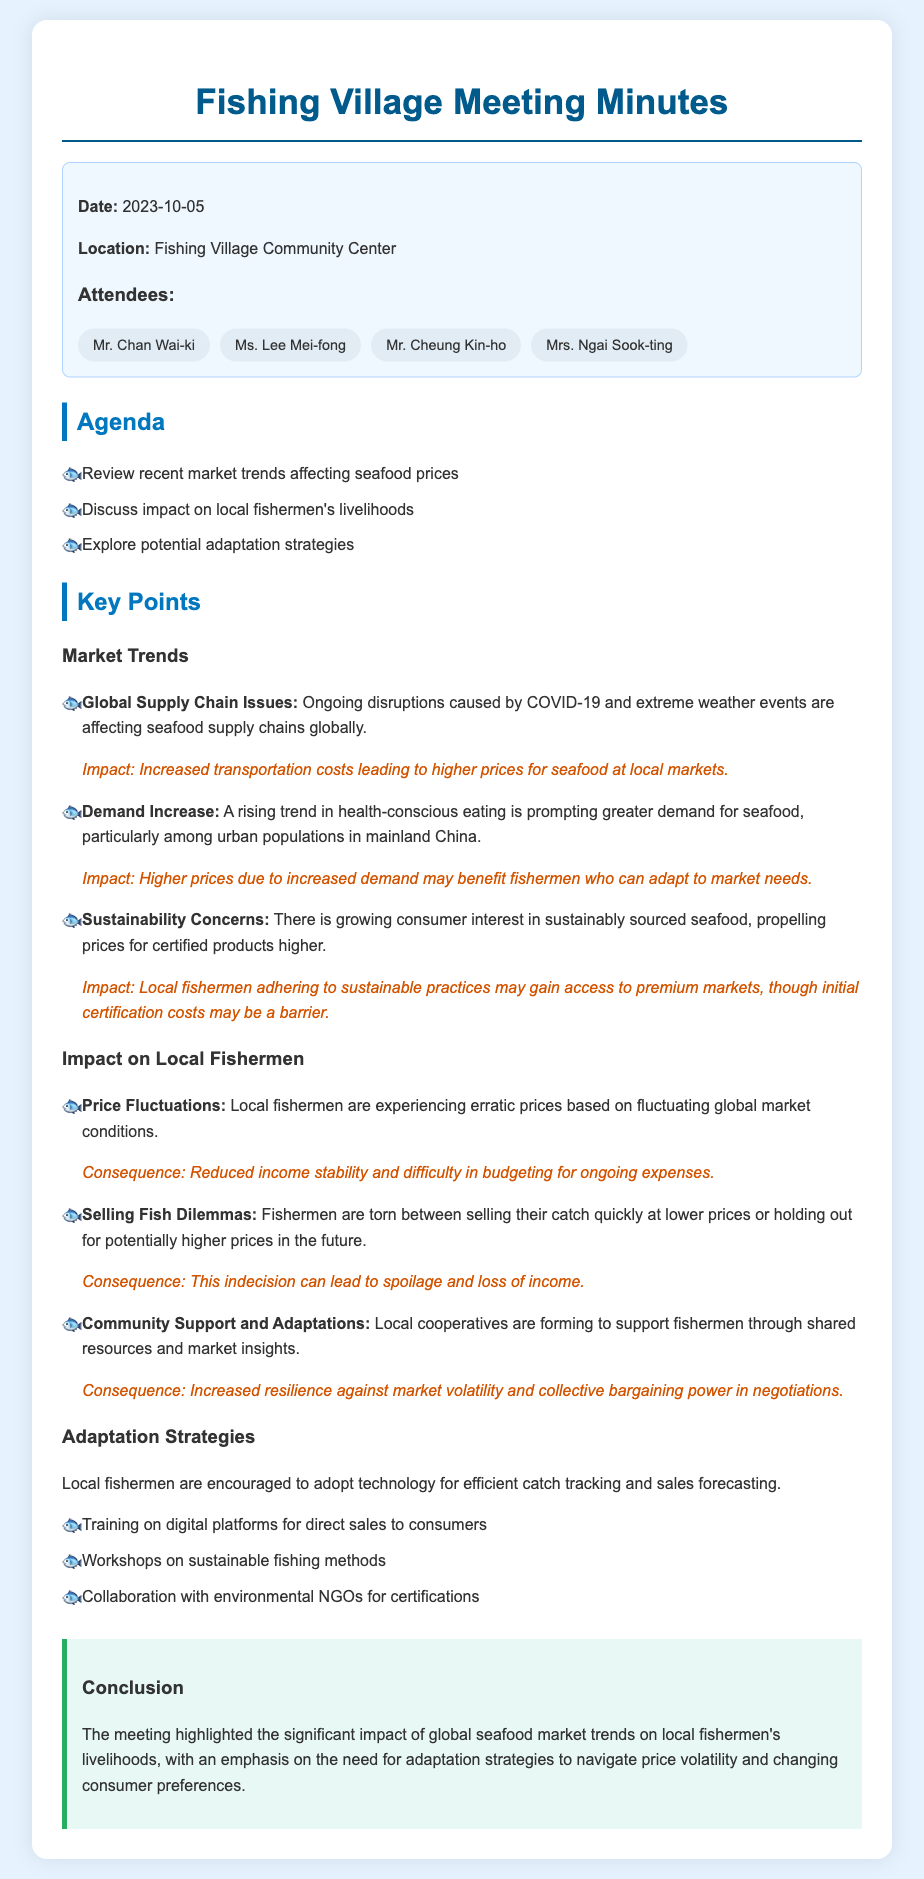What is the date of the meeting? The date of the meeting is stated at the beginning of the document.
Answer: 2023-10-05 Where was the meeting held? The location of the meeting is mentioned in the info box section.
Answer: Fishing Village Community Center Who is one of the attendees? The document lists several attendees in the information box.
Answer: Mr. Chan Wai-ki What is one of the market trends discussed? Market trends are noted under the Market Trends section of the document.
Answer: Global Supply Chain Issues What consequence do local fishermen face from price fluctuations? This information can be found in the Impact on Local Fishermen section, detailing specific consequences.
Answer: Reduced income stability What adaptation strategy is suggested for fishermen? Adaptation strategies are outlined towards the end of the document.
Answer: Training on digital platforms for direct sales to consumers What is one of the impacts of sustainability concerns? The impact related to sustainability concerns is detailed in the Market Trends section.
Answer: Local fishermen adhering to sustainable practices may gain access to premium markets How is community support helping local fishermen? The document explains community support in the Impact on Local Fishermen section.
Answer: Increased resilience against market volatility What is the focus of the meeting conclusion? The conclusion summarizes the main points discussed during the meeting.
Answer: The significant impact of global seafood market trends on local fishermen's livelihoods 